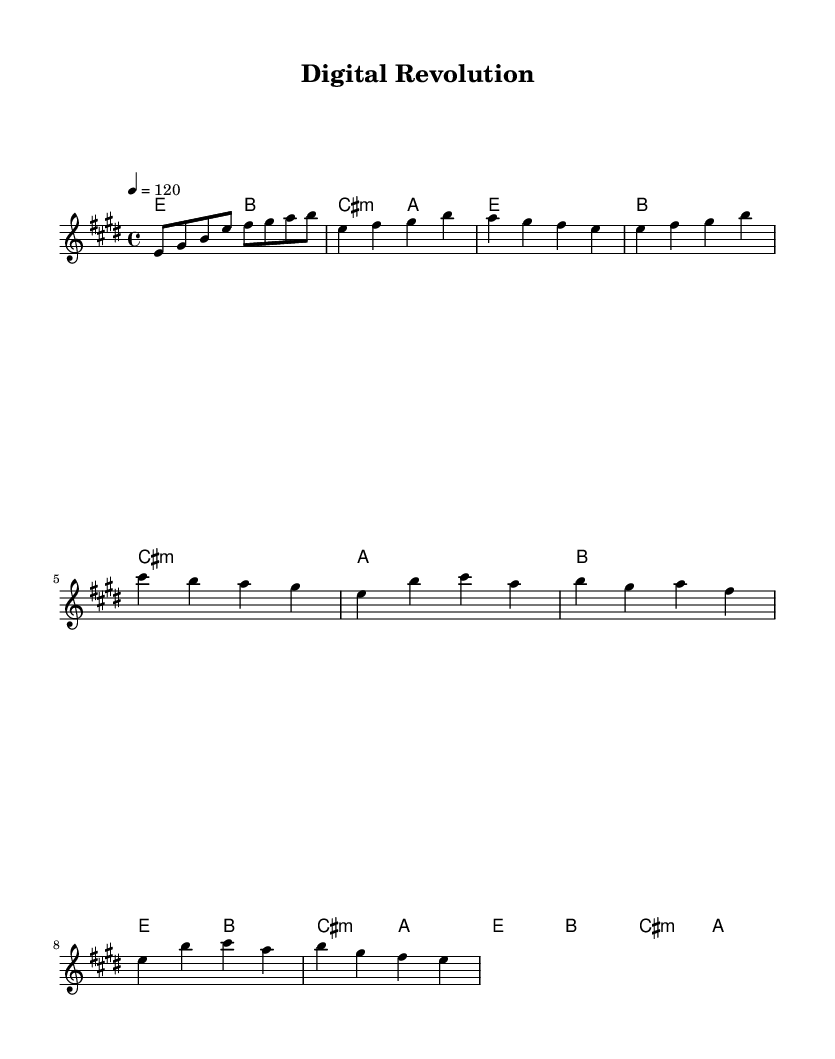What is the key signature of this music? The key signature is indicated at the beginning of the sheet music. Looking at the key signature for E major, it has four sharps: F#, C#, G#, and D#.
Answer: E major What is the time signature of this music? The time signature is found at the beginning of the piece, which indicates how many beats are in each measure. Here, 4/4 means there are four beats per measure, and the quarter note gets one beat.
Answer: 4/4 What is the tempo marking in this music? The tempo marking shows the speed of the piece and is found just before the beginning of the music. It indicates that there are 120 beats per minute.
Answer: 120 How many measures are in the chorus section? To determine the number of measures in the chorus, we can count each individual measure represented between the lyrics. There are four lines of lyrics in the chorus, and each line has two measures. Thus, there are a total of 8 measures.
Answer: 8 What is the lyrical theme of this song? The lyrics focus on technological progress and innovation, which includes ideas like digital revolution and the future being clear. The specific phrases in the lyrics emphasize a connection with technology and change.
Answer: Technological progress What chord accompanies the first line of the chorus? To find the chord that accompanies the first line of the chorus, we refer to the chord symbols above the melody. The first line of the chorus begins with the chords E and B.
Answer: E 